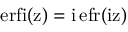<formula> <loc_0><loc_0><loc_500><loc_500>e r f i ( z ) = i \, e f r ( \mathrm { i z ) }</formula> 